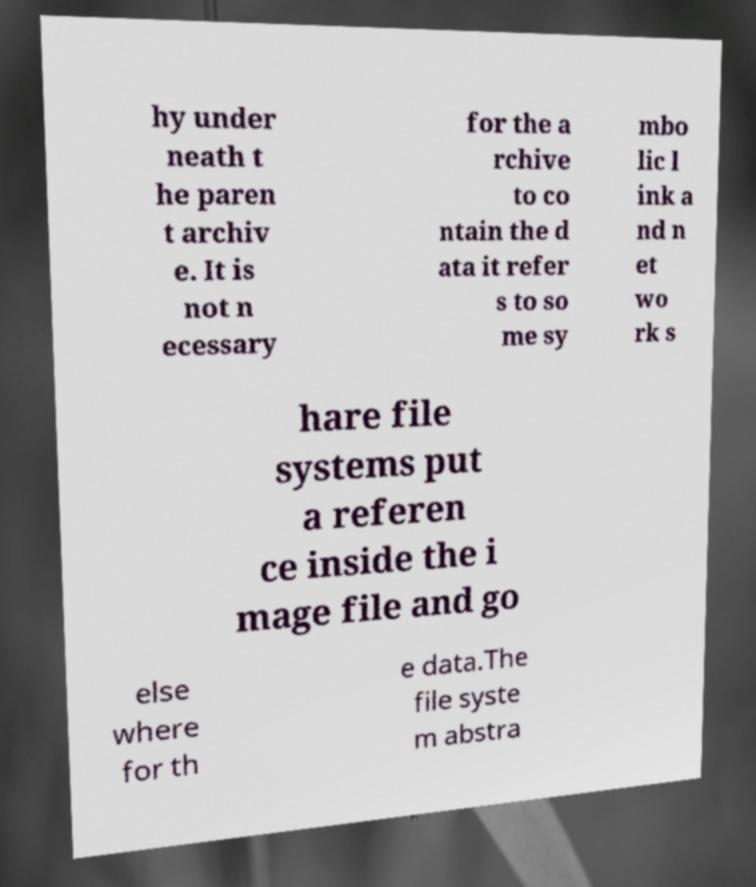Could you assist in decoding the text presented in this image and type it out clearly? hy under neath t he paren t archiv e. It is not n ecessary for the a rchive to co ntain the d ata it refer s to so me sy mbo lic l ink a nd n et wo rk s hare file systems put a referen ce inside the i mage file and go else where for th e data.The file syste m abstra 